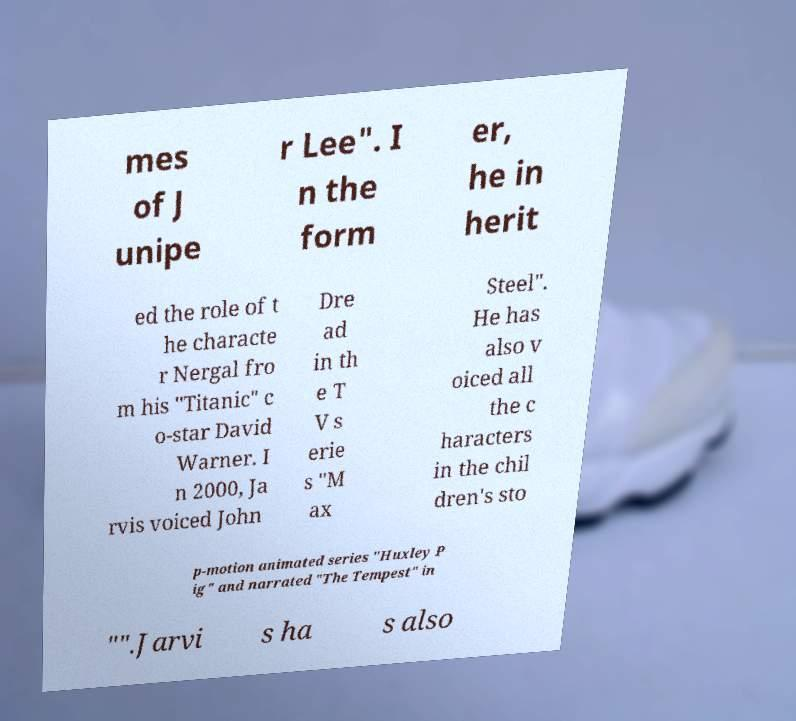Please identify and transcribe the text found in this image. mes of J unipe r Lee". I n the form er, he in herit ed the role of t he characte r Nergal fro m his "Titanic" c o-star David Warner. I n 2000, Ja rvis voiced John Dre ad in th e T V s erie s "M ax Steel". He has also v oiced all the c haracters in the chil dren's sto p-motion animated series "Huxley P ig" and narrated "The Tempest" in "".Jarvi s ha s also 